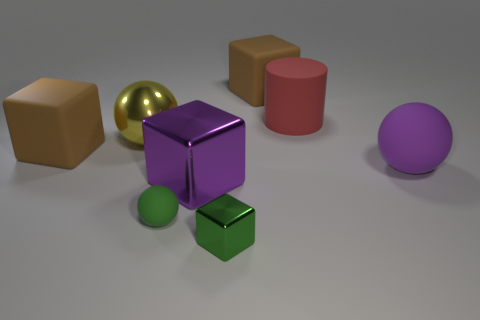Is there a tiny sphere of the same color as the large shiny sphere?
Your response must be concise. No. Are there fewer big red matte cylinders in front of the green metallic object than tiny green metallic things behind the big yellow shiny sphere?
Give a very brief answer. No. What is the large block that is in front of the big red matte thing and right of the yellow metallic sphere made of?
Offer a terse response. Metal. There is a red rubber object; is its shape the same as the purple thing that is to the left of the small block?
Your response must be concise. No. How many other objects are the same size as the red matte cylinder?
Provide a short and direct response. 5. Are there more purple metallic things than matte objects?
Provide a short and direct response. No. How many matte objects are both behind the big purple rubber object and to the left of the big purple shiny cube?
Provide a succinct answer. 1. The large red matte object that is to the right of the brown matte thing on the left side of the large purple metallic thing that is in front of the big purple matte ball is what shape?
Your answer should be very brief. Cylinder. Is there any other thing that has the same shape as the large yellow object?
Ensure brevity in your answer.  Yes. What number of cubes are either yellow things or big red matte objects?
Give a very brief answer. 0. 